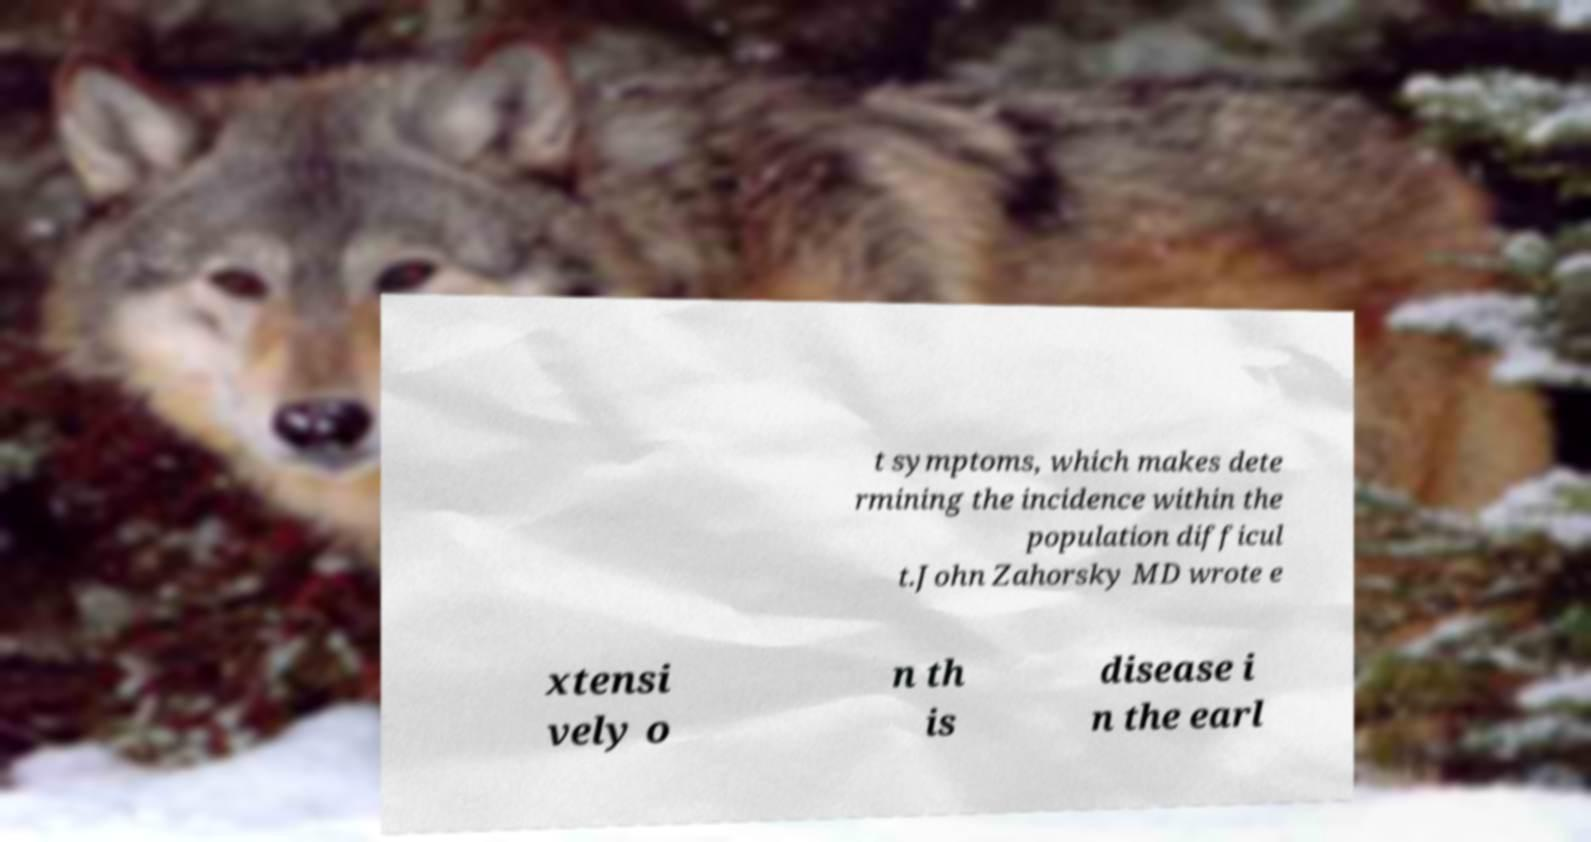Can you accurately transcribe the text from the provided image for me? t symptoms, which makes dete rmining the incidence within the population difficul t.John Zahorsky MD wrote e xtensi vely o n th is disease i n the earl 